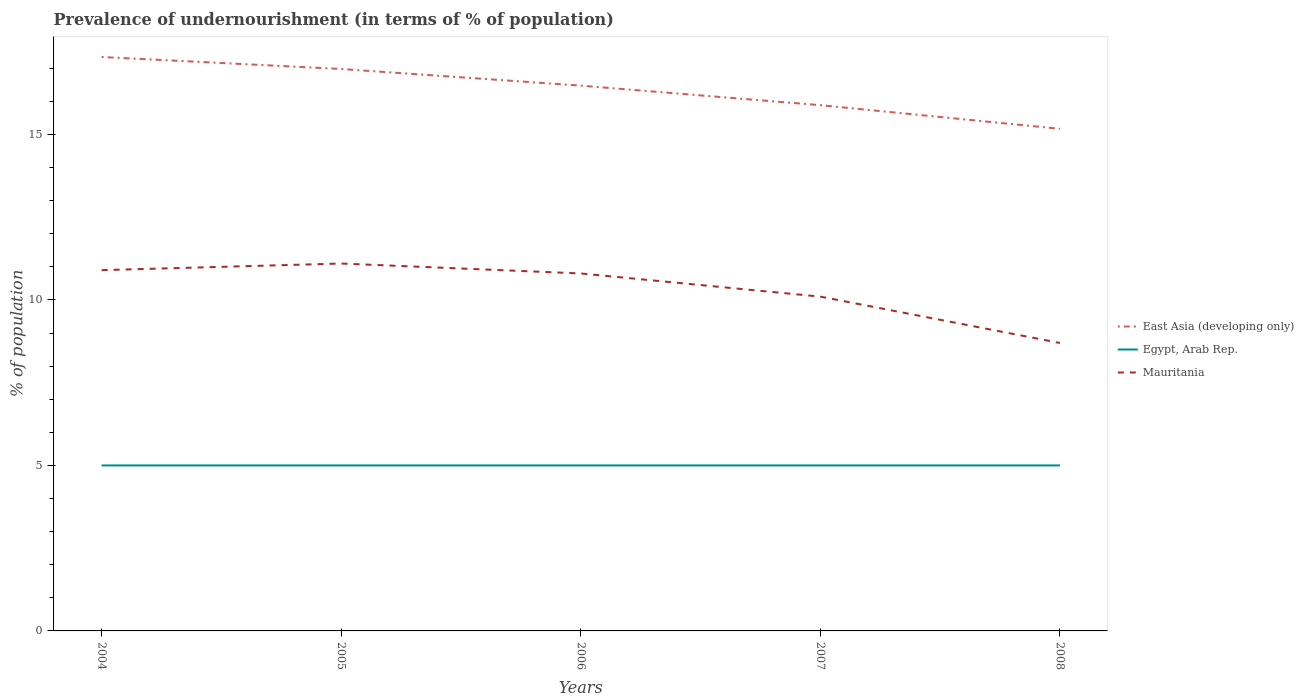How many different coloured lines are there?
Your answer should be very brief. 3. Does the line corresponding to Egypt, Arab Rep. intersect with the line corresponding to East Asia (developing only)?
Your answer should be compact. No. What is the difference between the highest and the second highest percentage of undernourished population in Mauritania?
Your response must be concise. 2.4. What is the difference between two consecutive major ticks on the Y-axis?
Provide a succinct answer. 5. Are the values on the major ticks of Y-axis written in scientific E-notation?
Offer a terse response. No. Does the graph contain any zero values?
Provide a short and direct response. No. Does the graph contain grids?
Your answer should be compact. No. Where does the legend appear in the graph?
Ensure brevity in your answer.  Center right. How many legend labels are there?
Provide a succinct answer. 3. How are the legend labels stacked?
Keep it short and to the point. Vertical. What is the title of the graph?
Your answer should be compact. Prevalence of undernourishment (in terms of % of population). Does "Euro area" appear as one of the legend labels in the graph?
Offer a very short reply. No. What is the label or title of the Y-axis?
Offer a terse response. % of population. What is the % of population in East Asia (developing only) in 2004?
Your response must be concise. 17.34. What is the % of population in Mauritania in 2004?
Your answer should be compact. 10.9. What is the % of population of East Asia (developing only) in 2005?
Your answer should be very brief. 16.98. What is the % of population of East Asia (developing only) in 2006?
Provide a short and direct response. 16.47. What is the % of population in Egypt, Arab Rep. in 2006?
Offer a terse response. 5. What is the % of population in Mauritania in 2006?
Make the answer very short. 10.8. What is the % of population of East Asia (developing only) in 2007?
Offer a terse response. 15.88. What is the % of population of Mauritania in 2007?
Make the answer very short. 10.1. What is the % of population of East Asia (developing only) in 2008?
Provide a short and direct response. 15.17. What is the % of population of Egypt, Arab Rep. in 2008?
Your answer should be compact. 5. What is the % of population in Mauritania in 2008?
Your answer should be compact. 8.7. Across all years, what is the maximum % of population in East Asia (developing only)?
Offer a very short reply. 17.34. Across all years, what is the maximum % of population in Egypt, Arab Rep.?
Your answer should be very brief. 5. Across all years, what is the minimum % of population of East Asia (developing only)?
Provide a succinct answer. 15.17. Across all years, what is the minimum % of population in Egypt, Arab Rep.?
Offer a terse response. 5. Across all years, what is the minimum % of population in Mauritania?
Give a very brief answer. 8.7. What is the total % of population in East Asia (developing only) in the graph?
Your answer should be compact. 81.85. What is the total % of population of Mauritania in the graph?
Your response must be concise. 51.6. What is the difference between the % of population in East Asia (developing only) in 2004 and that in 2005?
Provide a short and direct response. 0.36. What is the difference between the % of population of Mauritania in 2004 and that in 2005?
Your response must be concise. -0.2. What is the difference between the % of population of East Asia (developing only) in 2004 and that in 2006?
Your answer should be very brief. 0.86. What is the difference between the % of population in Egypt, Arab Rep. in 2004 and that in 2006?
Provide a short and direct response. 0. What is the difference between the % of population of East Asia (developing only) in 2004 and that in 2007?
Offer a terse response. 1.46. What is the difference between the % of population of Egypt, Arab Rep. in 2004 and that in 2007?
Offer a very short reply. 0. What is the difference between the % of population in Mauritania in 2004 and that in 2007?
Keep it short and to the point. 0.8. What is the difference between the % of population in East Asia (developing only) in 2004 and that in 2008?
Give a very brief answer. 2.17. What is the difference between the % of population of Egypt, Arab Rep. in 2004 and that in 2008?
Provide a succinct answer. 0. What is the difference between the % of population in Mauritania in 2004 and that in 2008?
Give a very brief answer. 2.2. What is the difference between the % of population in East Asia (developing only) in 2005 and that in 2006?
Your response must be concise. 0.5. What is the difference between the % of population of Egypt, Arab Rep. in 2005 and that in 2006?
Provide a short and direct response. 0. What is the difference between the % of population of East Asia (developing only) in 2005 and that in 2007?
Offer a terse response. 1.09. What is the difference between the % of population of Egypt, Arab Rep. in 2005 and that in 2007?
Your response must be concise. 0. What is the difference between the % of population of Mauritania in 2005 and that in 2007?
Offer a very short reply. 1. What is the difference between the % of population in East Asia (developing only) in 2005 and that in 2008?
Your answer should be compact. 1.81. What is the difference between the % of population of East Asia (developing only) in 2006 and that in 2007?
Provide a short and direct response. 0.59. What is the difference between the % of population of East Asia (developing only) in 2006 and that in 2008?
Keep it short and to the point. 1.3. What is the difference between the % of population of Mauritania in 2006 and that in 2008?
Provide a short and direct response. 2.1. What is the difference between the % of population in Egypt, Arab Rep. in 2007 and that in 2008?
Your answer should be compact. 0. What is the difference between the % of population of East Asia (developing only) in 2004 and the % of population of Egypt, Arab Rep. in 2005?
Give a very brief answer. 12.34. What is the difference between the % of population in East Asia (developing only) in 2004 and the % of population in Mauritania in 2005?
Keep it short and to the point. 6.24. What is the difference between the % of population of East Asia (developing only) in 2004 and the % of population of Egypt, Arab Rep. in 2006?
Your response must be concise. 12.34. What is the difference between the % of population of East Asia (developing only) in 2004 and the % of population of Mauritania in 2006?
Offer a very short reply. 6.54. What is the difference between the % of population in East Asia (developing only) in 2004 and the % of population in Egypt, Arab Rep. in 2007?
Keep it short and to the point. 12.34. What is the difference between the % of population of East Asia (developing only) in 2004 and the % of population of Mauritania in 2007?
Ensure brevity in your answer.  7.24. What is the difference between the % of population in Egypt, Arab Rep. in 2004 and the % of population in Mauritania in 2007?
Offer a very short reply. -5.1. What is the difference between the % of population in East Asia (developing only) in 2004 and the % of population in Egypt, Arab Rep. in 2008?
Offer a very short reply. 12.34. What is the difference between the % of population of East Asia (developing only) in 2004 and the % of population of Mauritania in 2008?
Your answer should be very brief. 8.64. What is the difference between the % of population of East Asia (developing only) in 2005 and the % of population of Egypt, Arab Rep. in 2006?
Provide a short and direct response. 11.98. What is the difference between the % of population in East Asia (developing only) in 2005 and the % of population in Mauritania in 2006?
Your answer should be compact. 6.18. What is the difference between the % of population in Egypt, Arab Rep. in 2005 and the % of population in Mauritania in 2006?
Offer a very short reply. -5.8. What is the difference between the % of population of East Asia (developing only) in 2005 and the % of population of Egypt, Arab Rep. in 2007?
Your answer should be compact. 11.98. What is the difference between the % of population of East Asia (developing only) in 2005 and the % of population of Mauritania in 2007?
Your response must be concise. 6.88. What is the difference between the % of population of East Asia (developing only) in 2005 and the % of population of Egypt, Arab Rep. in 2008?
Ensure brevity in your answer.  11.98. What is the difference between the % of population in East Asia (developing only) in 2005 and the % of population in Mauritania in 2008?
Give a very brief answer. 8.28. What is the difference between the % of population in East Asia (developing only) in 2006 and the % of population in Egypt, Arab Rep. in 2007?
Your response must be concise. 11.47. What is the difference between the % of population of East Asia (developing only) in 2006 and the % of population of Mauritania in 2007?
Your answer should be very brief. 6.37. What is the difference between the % of population in Egypt, Arab Rep. in 2006 and the % of population in Mauritania in 2007?
Keep it short and to the point. -5.1. What is the difference between the % of population in East Asia (developing only) in 2006 and the % of population in Egypt, Arab Rep. in 2008?
Your answer should be compact. 11.47. What is the difference between the % of population in East Asia (developing only) in 2006 and the % of population in Mauritania in 2008?
Keep it short and to the point. 7.77. What is the difference between the % of population of East Asia (developing only) in 2007 and the % of population of Egypt, Arab Rep. in 2008?
Provide a short and direct response. 10.88. What is the difference between the % of population of East Asia (developing only) in 2007 and the % of population of Mauritania in 2008?
Keep it short and to the point. 7.18. What is the average % of population in East Asia (developing only) per year?
Give a very brief answer. 16.37. What is the average % of population in Mauritania per year?
Offer a very short reply. 10.32. In the year 2004, what is the difference between the % of population in East Asia (developing only) and % of population in Egypt, Arab Rep.?
Provide a short and direct response. 12.34. In the year 2004, what is the difference between the % of population in East Asia (developing only) and % of population in Mauritania?
Keep it short and to the point. 6.44. In the year 2004, what is the difference between the % of population in Egypt, Arab Rep. and % of population in Mauritania?
Provide a short and direct response. -5.9. In the year 2005, what is the difference between the % of population in East Asia (developing only) and % of population in Egypt, Arab Rep.?
Provide a short and direct response. 11.98. In the year 2005, what is the difference between the % of population of East Asia (developing only) and % of population of Mauritania?
Your answer should be compact. 5.88. In the year 2005, what is the difference between the % of population of Egypt, Arab Rep. and % of population of Mauritania?
Ensure brevity in your answer.  -6.1. In the year 2006, what is the difference between the % of population in East Asia (developing only) and % of population in Egypt, Arab Rep.?
Make the answer very short. 11.47. In the year 2006, what is the difference between the % of population of East Asia (developing only) and % of population of Mauritania?
Offer a very short reply. 5.67. In the year 2007, what is the difference between the % of population of East Asia (developing only) and % of population of Egypt, Arab Rep.?
Provide a succinct answer. 10.88. In the year 2007, what is the difference between the % of population in East Asia (developing only) and % of population in Mauritania?
Offer a terse response. 5.78. In the year 2008, what is the difference between the % of population in East Asia (developing only) and % of population in Egypt, Arab Rep.?
Give a very brief answer. 10.17. In the year 2008, what is the difference between the % of population in East Asia (developing only) and % of population in Mauritania?
Offer a very short reply. 6.47. What is the ratio of the % of population of East Asia (developing only) in 2004 to that in 2005?
Give a very brief answer. 1.02. What is the ratio of the % of population in Mauritania in 2004 to that in 2005?
Offer a terse response. 0.98. What is the ratio of the % of population of East Asia (developing only) in 2004 to that in 2006?
Offer a very short reply. 1.05. What is the ratio of the % of population of Egypt, Arab Rep. in 2004 to that in 2006?
Offer a very short reply. 1. What is the ratio of the % of population in Mauritania in 2004 to that in 2006?
Offer a terse response. 1.01. What is the ratio of the % of population in East Asia (developing only) in 2004 to that in 2007?
Provide a short and direct response. 1.09. What is the ratio of the % of population of Egypt, Arab Rep. in 2004 to that in 2007?
Provide a short and direct response. 1. What is the ratio of the % of population of Mauritania in 2004 to that in 2007?
Keep it short and to the point. 1.08. What is the ratio of the % of population of East Asia (developing only) in 2004 to that in 2008?
Provide a short and direct response. 1.14. What is the ratio of the % of population in Egypt, Arab Rep. in 2004 to that in 2008?
Offer a very short reply. 1. What is the ratio of the % of population in Mauritania in 2004 to that in 2008?
Provide a succinct answer. 1.25. What is the ratio of the % of population of East Asia (developing only) in 2005 to that in 2006?
Give a very brief answer. 1.03. What is the ratio of the % of population of Mauritania in 2005 to that in 2006?
Offer a terse response. 1.03. What is the ratio of the % of population in East Asia (developing only) in 2005 to that in 2007?
Your response must be concise. 1.07. What is the ratio of the % of population in Egypt, Arab Rep. in 2005 to that in 2007?
Keep it short and to the point. 1. What is the ratio of the % of population of Mauritania in 2005 to that in 2007?
Your answer should be very brief. 1.1. What is the ratio of the % of population of East Asia (developing only) in 2005 to that in 2008?
Make the answer very short. 1.12. What is the ratio of the % of population in Mauritania in 2005 to that in 2008?
Your answer should be compact. 1.28. What is the ratio of the % of population of East Asia (developing only) in 2006 to that in 2007?
Ensure brevity in your answer.  1.04. What is the ratio of the % of population of Mauritania in 2006 to that in 2007?
Give a very brief answer. 1.07. What is the ratio of the % of population of East Asia (developing only) in 2006 to that in 2008?
Provide a short and direct response. 1.09. What is the ratio of the % of population of Egypt, Arab Rep. in 2006 to that in 2008?
Keep it short and to the point. 1. What is the ratio of the % of population of Mauritania in 2006 to that in 2008?
Provide a succinct answer. 1.24. What is the ratio of the % of population in East Asia (developing only) in 2007 to that in 2008?
Keep it short and to the point. 1.05. What is the ratio of the % of population in Egypt, Arab Rep. in 2007 to that in 2008?
Keep it short and to the point. 1. What is the ratio of the % of population in Mauritania in 2007 to that in 2008?
Provide a short and direct response. 1.16. What is the difference between the highest and the second highest % of population of East Asia (developing only)?
Offer a terse response. 0.36. What is the difference between the highest and the second highest % of population in Mauritania?
Ensure brevity in your answer.  0.2. What is the difference between the highest and the lowest % of population of East Asia (developing only)?
Keep it short and to the point. 2.17. What is the difference between the highest and the lowest % of population of Egypt, Arab Rep.?
Offer a terse response. 0. 